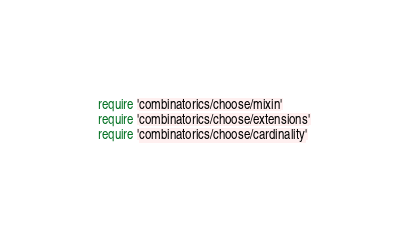<code> <loc_0><loc_0><loc_500><loc_500><_Ruby_>require 'combinatorics/choose/mixin'
require 'combinatorics/choose/extensions'
require 'combinatorics/choose/cardinality'
</code> 